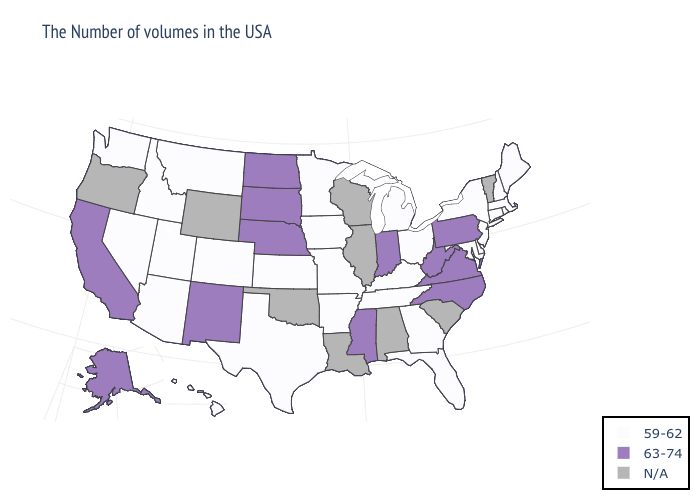Name the states that have a value in the range 59-62?
Give a very brief answer. Maine, Massachusetts, Rhode Island, New Hampshire, Connecticut, New York, New Jersey, Delaware, Maryland, Ohio, Florida, Georgia, Michigan, Kentucky, Tennessee, Missouri, Arkansas, Minnesota, Iowa, Kansas, Texas, Colorado, Utah, Montana, Arizona, Idaho, Nevada, Washington, Hawaii. Name the states that have a value in the range 63-74?
Answer briefly. Pennsylvania, Virginia, North Carolina, West Virginia, Indiana, Mississippi, Nebraska, South Dakota, North Dakota, New Mexico, California, Alaska. Name the states that have a value in the range 63-74?
Short answer required. Pennsylvania, Virginia, North Carolina, West Virginia, Indiana, Mississippi, Nebraska, South Dakota, North Dakota, New Mexico, California, Alaska. Among the states that border South Dakota , does North Dakota have the highest value?
Be succinct. Yes. Which states have the lowest value in the USA?
Be succinct. Maine, Massachusetts, Rhode Island, New Hampshire, Connecticut, New York, New Jersey, Delaware, Maryland, Ohio, Florida, Georgia, Michigan, Kentucky, Tennessee, Missouri, Arkansas, Minnesota, Iowa, Kansas, Texas, Colorado, Utah, Montana, Arizona, Idaho, Nevada, Washington, Hawaii. What is the value of Hawaii?
Concise answer only. 59-62. What is the value of North Carolina?
Write a very short answer. 63-74. Name the states that have a value in the range N/A?
Give a very brief answer. Vermont, South Carolina, Alabama, Wisconsin, Illinois, Louisiana, Oklahoma, Wyoming, Oregon. Does Alaska have the lowest value in the USA?
Concise answer only. No. What is the value of Washington?
Concise answer only. 59-62. Name the states that have a value in the range N/A?
Short answer required. Vermont, South Carolina, Alabama, Wisconsin, Illinois, Louisiana, Oklahoma, Wyoming, Oregon. Which states have the lowest value in the USA?
Concise answer only. Maine, Massachusetts, Rhode Island, New Hampshire, Connecticut, New York, New Jersey, Delaware, Maryland, Ohio, Florida, Georgia, Michigan, Kentucky, Tennessee, Missouri, Arkansas, Minnesota, Iowa, Kansas, Texas, Colorado, Utah, Montana, Arizona, Idaho, Nevada, Washington, Hawaii. Name the states that have a value in the range 63-74?
Keep it brief. Pennsylvania, Virginia, North Carolina, West Virginia, Indiana, Mississippi, Nebraska, South Dakota, North Dakota, New Mexico, California, Alaska. What is the value of Arizona?
Keep it brief. 59-62. 